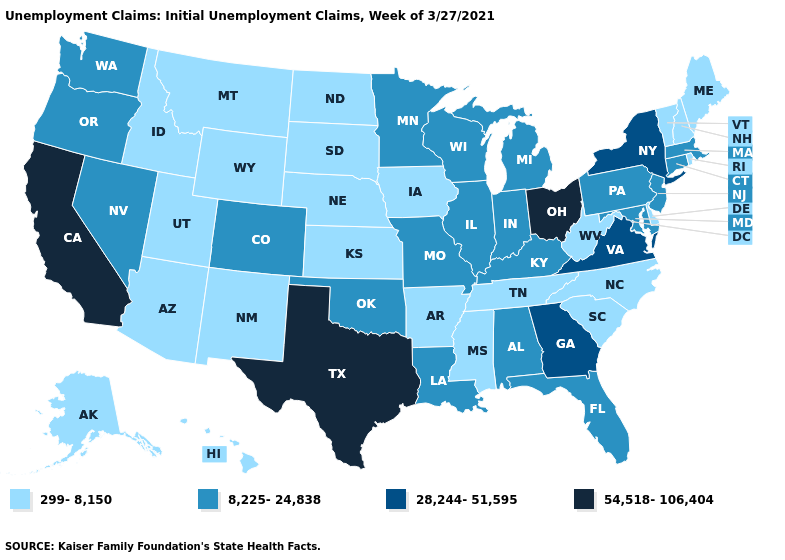How many symbols are there in the legend?
Be succinct. 4. Does the map have missing data?
Short answer required. No. Does New York have the highest value in the Northeast?
Give a very brief answer. Yes. Among the states that border Idaho , which have the highest value?
Concise answer only. Nevada, Oregon, Washington. Which states have the highest value in the USA?
Quick response, please. California, Ohio, Texas. Does Iowa have the highest value in the USA?
Short answer required. No. Among the states that border Maine , which have the lowest value?
Keep it brief. New Hampshire. Does South Dakota have the same value as Mississippi?
Quick response, please. Yes. Does Texas have the highest value in the South?
Give a very brief answer. Yes. Does Montana have a higher value than South Carolina?
Be succinct. No. Name the states that have a value in the range 54,518-106,404?
Keep it brief. California, Ohio, Texas. Name the states that have a value in the range 8,225-24,838?
Write a very short answer. Alabama, Colorado, Connecticut, Florida, Illinois, Indiana, Kentucky, Louisiana, Maryland, Massachusetts, Michigan, Minnesota, Missouri, Nevada, New Jersey, Oklahoma, Oregon, Pennsylvania, Washington, Wisconsin. Does New Mexico have the lowest value in the West?
Short answer required. Yes. How many symbols are there in the legend?
Concise answer only. 4. What is the lowest value in the USA?
Short answer required. 299-8,150. 